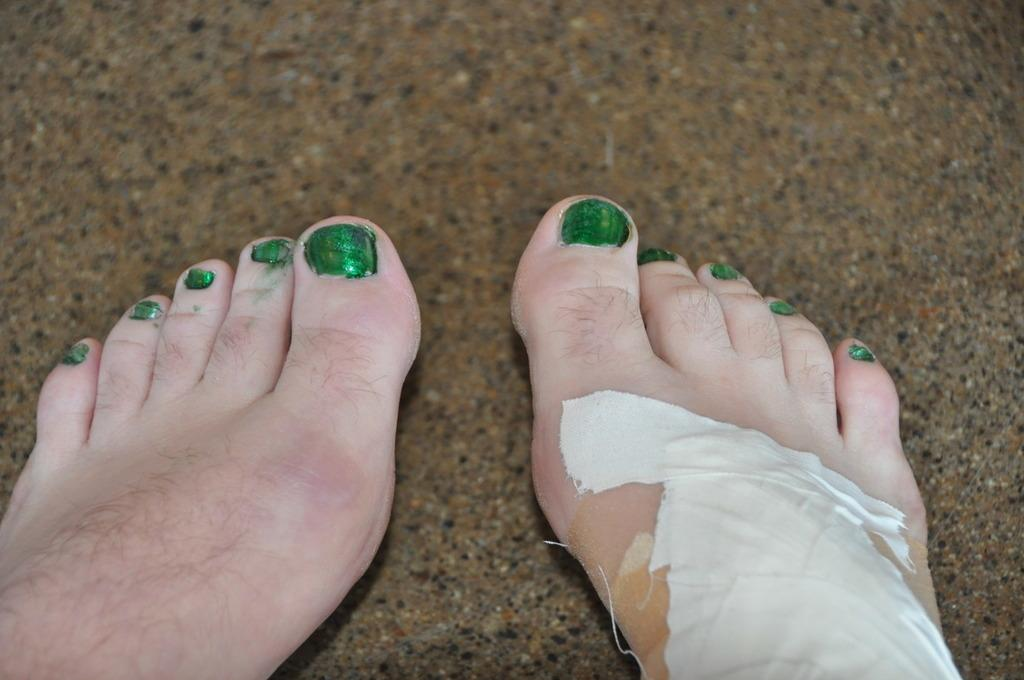What is present in the image? There is a person in the image. Can you describe any specific details about the person? The person has a bandage on their feet. What type of jeans is the person wearing in the image? There is no information about jeans in the image; the only detail mentioned is the bandage on the person's feet. Can you tell me what type of badge the person is wearing in the image? There is no badge present in the image. 